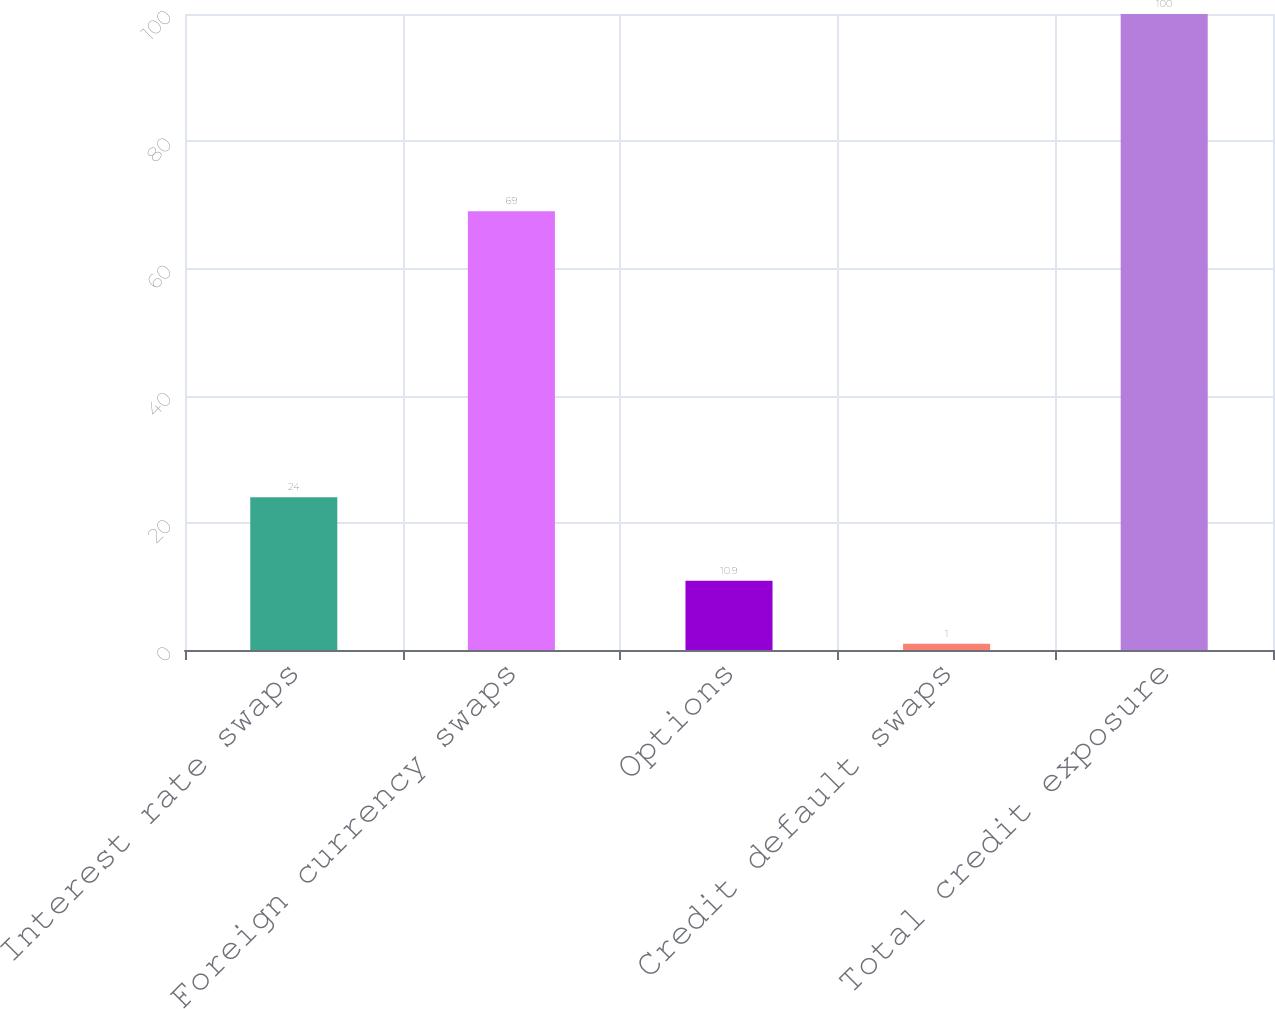<chart> <loc_0><loc_0><loc_500><loc_500><bar_chart><fcel>Interest rate swaps<fcel>Foreign currency swaps<fcel>Options<fcel>Credit default swaps<fcel>Total credit exposure<nl><fcel>24<fcel>69<fcel>10.9<fcel>1<fcel>100<nl></chart> 